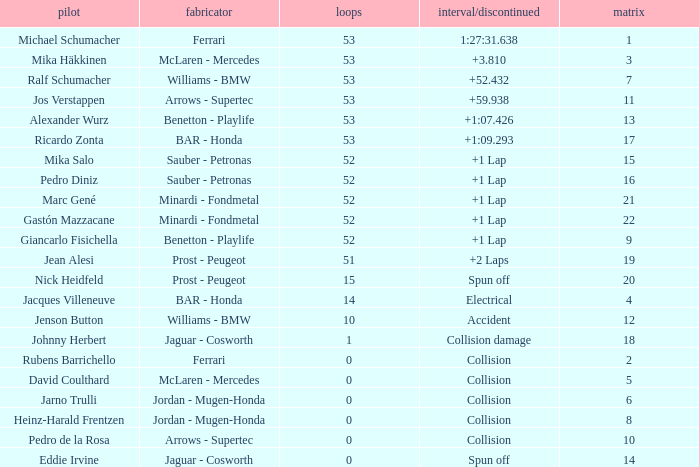Help me parse the entirety of this table. {'header': ['pilot', 'fabricator', 'loops', 'interval/discontinued', 'matrix'], 'rows': [['Michael Schumacher', 'Ferrari', '53', '1:27:31.638', '1'], ['Mika Häkkinen', 'McLaren - Mercedes', '53', '+3.810', '3'], ['Ralf Schumacher', 'Williams - BMW', '53', '+52.432', '7'], ['Jos Verstappen', 'Arrows - Supertec', '53', '+59.938', '11'], ['Alexander Wurz', 'Benetton - Playlife', '53', '+1:07.426', '13'], ['Ricardo Zonta', 'BAR - Honda', '53', '+1:09.293', '17'], ['Mika Salo', 'Sauber - Petronas', '52', '+1 Lap', '15'], ['Pedro Diniz', 'Sauber - Petronas', '52', '+1 Lap', '16'], ['Marc Gené', 'Minardi - Fondmetal', '52', '+1 Lap', '21'], ['Gastón Mazzacane', 'Minardi - Fondmetal', '52', '+1 Lap', '22'], ['Giancarlo Fisichella', 'Benetton - Playlife', '52', '+1 Lap', '9'], ['Jean Alesi', 'Prost - Peugeot', '51', '+2 Laps', '19'], ['Nick Heidfeld', 'Prost - Peugeot', '15', 'Spun off', '20'], ['Jacques Villeneuve', 'BAR - Honda', '14', 'Electrical', '4'], ['Jenson Button', 'Williams - BMW', '10', 'Accident', '12'], ['Johnny Herbert', 'Jaguar - Cosworth', '1', 'Collision damage', '18'], ['Rubens Barrichello', 'Ferrari', '0', 'Collision', '2'], ['David Coulthard', 'McLaren - Mercedes', '0', 'Collision', '5'], ['Jarno Trulli', 'Jordan - Mugen-Honda', '0', 'Collision', '6'], ['Heinz-Harald Frentzen', 'Jordan - Mugen-Honda', '0', 'Collision', '8'], ['Pedro de la Rosa', 'Arrows - Supertec', '0', 'Collision', '10'], ['Eddie Irvine', 'Jaguar - Cosworth', '0', 'Spun off', '14']]} What is the average Laps for a grid smaller than 17, and a Constructor of williams - bmw, driven by jenson button? 10.0. 